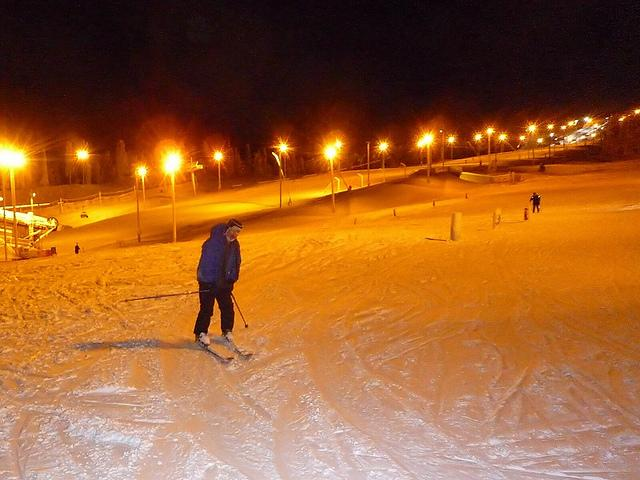Why is there so much orange in this image?

Choices:
A) sunset
B) orange filter
C) orange lights
D) sunrise orange lights 